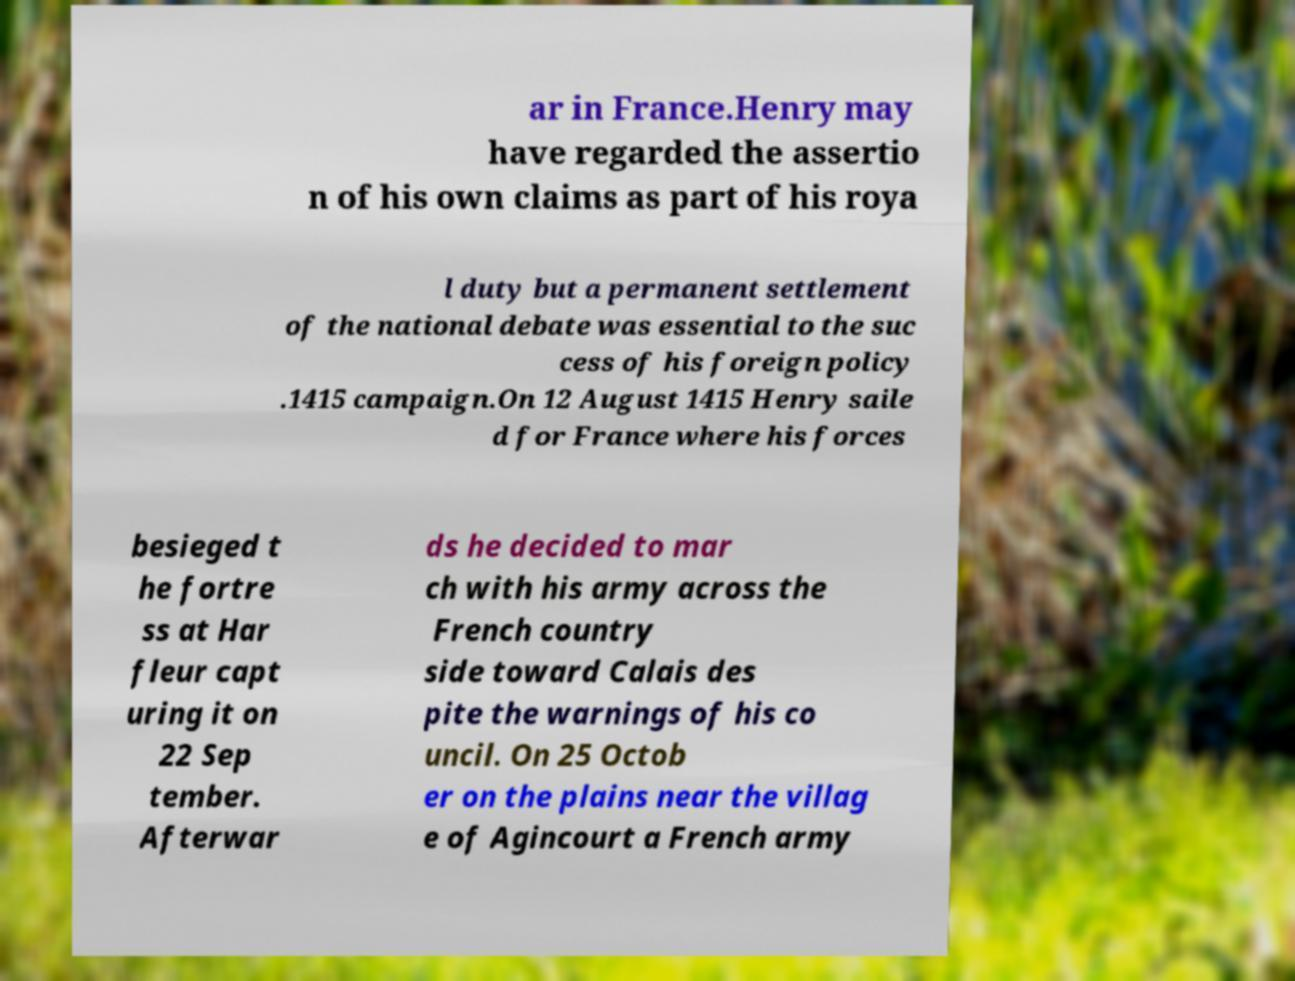Can you accurately transcribe the text from the provided image for me? ar in France.Henry may have regarded the assertio n of his own claims as part of his roya l duty but a permanent settlement of the national debate was essential to the suc cess of his foreign policy .1415 campaign.On 12 August 1415 Henry saile d for France where his forces besieged t he fortre ss at Har fleur capt uring it on 22 Sep tember. Afterwar ds he decided to mar ch with his army across the French country side toward Calais des pite the warnings of his co uncil. On 25 Octob er on the plains near the villag e of Agincourt a French army 